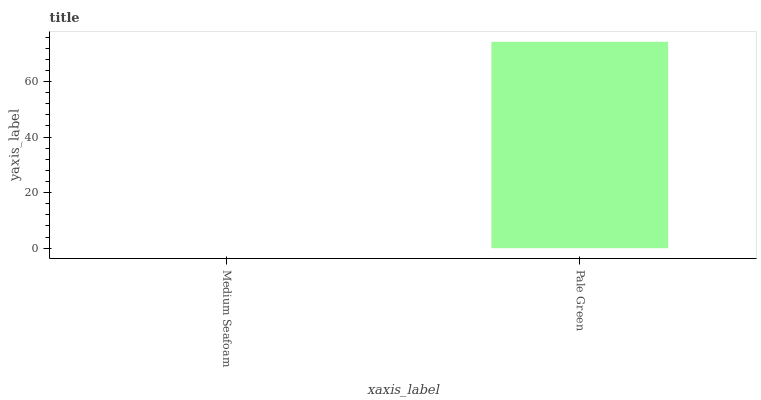Is Medium Seafoam the minimum?
Answer yes or no. Yes. Is Pale Green the maximum?
Answer yes or no. Yes. Is Pale Green the minimum?
Answer yes or no. No. Is Pale Green greater than Medium Seafoam?
Answer yes or no. Yes. Is Medium Seafoam less than Pale Green?
Answer yes or no. Yes. Is Medium Seafoam greater than Pale Green?
Answer yes or no. No. Is Pale Green less than Medium Seafoam?
Answer yes or no. No. Is Pale Green the high median?
Answer yes or no. Yes. Is Medium Seafoam the low median?
Answer yes or no. Yes. Is Medium Seafoam the high median?
Answer yes or no. No. Is Pale Green the low median?
Answer yes or no. No. 